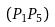Convert formula to latex. <formula><loc_0><loc_0><loc_500><loc_500>( P _ { 1 } P _ { 5 } )</formula> 